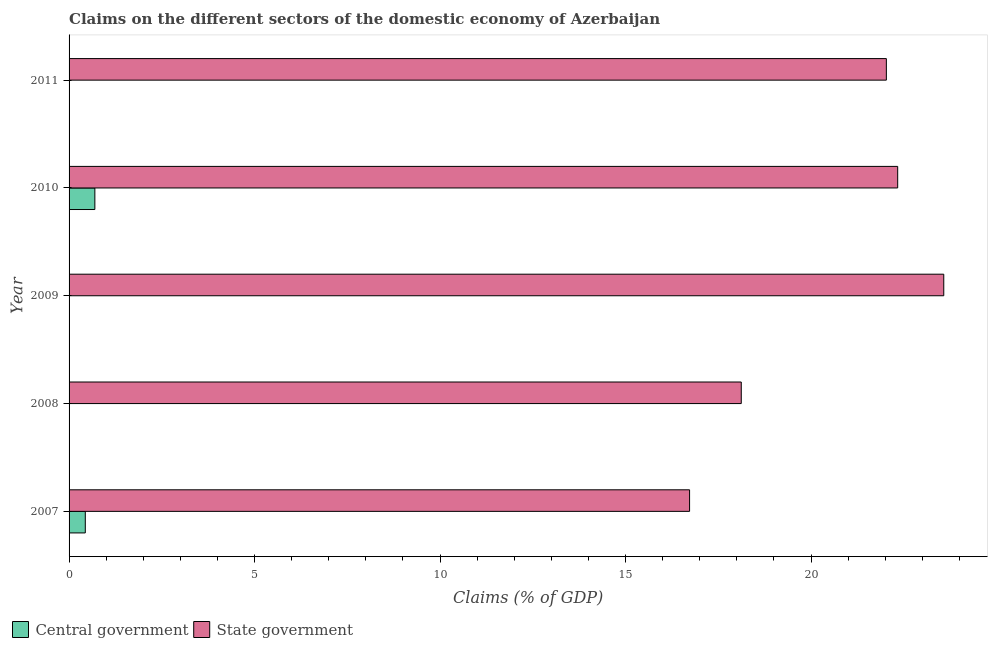How many different coloured bars are there?
Provide a succinct answer. 2. What is the label of the 1st group of bars from the top?
Provide a short and direct response. 2011. In how many cases, is the number of bars for a given year not equal to the number of legend labels?
Offer a very short reply. 3. What is the claims on state government in 2007?
Your answer should be very brief. 16.73. Across all years, what is the maximum claims on central government?
Offer a terse response. 0.69. Across all years, what is the minimum claims on state government?
Give a very brief answer. 16.73. What is the total claims on central government in the graph?
Provide a short and direct response. 1.13. What is the difference between the claims on state government in 2007 and that in 2008?
Offer a terse response. -1.39. What is the difference between the claims on state government in 2008 and the claims on central government in 2010?
Keep it short and to the point. 17.42. What is the average claims on state government per year?
Ensure brevity in your answer.  20.56. In the year 2010, what is the difference between the claims on central government and claims on state government?
Offer a very short reply. -21.64. What is the ratio of the claims on state government in 2007 to that in 2008?
Give a very brief answer. 0.92. What is the difference between the highest and the second highest claims on state government?
Your answer should be compact. 1.24. What is the difference between the highest and the lowest claims on central government?
Provide a succinct answer. 0.69. Is the sum of the claims on state government in 2009 and 2010 greater than the maximum claims on central government across all years?
Provide a short and direct response. Yes. How many bars are there?
Your answer should be compact. 7. Are all the bars in the graph horizontal?
Provide a short and direct response. Yes. What is the difference between two consecutive major ticks on the X-axis?
Keep it short and to the point. 5. Does the graph contain any zero values?
Keep it short and to the point. Yes. How many legend labels are there?
Keep it short and to the point. 2. How are the legend labels stacked?
Offer a terse response. Horizontal. What is the title of the graph?
Offer a very short reply. Claims on the different sectors of the domestic economy of Azerbaijan. Does "Commercial service exports" appear as one of the legend labels in the graph?
Your answer should be compact. No. What is the label or title of the X-axis?
Keep it short and to the point. Claims (% of GDP). What is the Claims (% of GDP) of Central government in 2007?
Your answer should be very brief. 0.44. What is the Claims (% of GDP) in State government in 2007?
Provide a succinct answer. 16.73. What is the Claims (% of GDP) in Central government in 2008?
Your answer should be very brief. 0. What is the Claims (% of GDP) of State government in 2008?
Ensure brevity in your answer.  18.12. What is the Claims (% of GDP) of Central government in 2009?
Your answer should be very brief. 0. What is the Claims (% of GDP) of State government in 2009?
Give a very brief answer. 23.58. What is the Claims (% of GDP) in Central government in 2010?
Provide a short and direct response. 0.69. What is the Claims (% of GDP) in State government in 2010?
Your answer should be compact. 22.33. What is the Claims (% of GDP) in Central government in 2011?
Your answer should be compact. 0. What is the Claims (% of GDP) of State government in 2011?
Your answer should be compact. 22.03. Across all years, what is the maximum Claims (% of GDP) of Central government?
Make the answer very short. 0.69. Across all years, what is the maximum Claims (% of GDP) in State government?
Your answer should be compact. 23.58. Across all years, what is the minimum Claims (% of GDP) in Central government?
Your answer should be compact. 0. Across all years, what is the minimum Claims (% of GDP) in State government?
Your answer should be compact. 16.73. What is the total Claims (% of GDP) in Central government in the graph?
Make the answer very short. 1.13. What is the total Claims (% of GDP) in State government in the graph?
Make the answer very short. 102.78. What is the difference between the Claims (% of GDP) of State government in 2007 and that in 2008?
Provide a short and direct response. -1.39. What is the difference between the Claims (% of GDP) of State government in 2007 and that in 2009?
Make the answer very short. -6.85. What is the difference between the Claims (% of GDP) in Central government in 2007 and that in 2010?
Give a very brief answer. -0.26. What is the difference between the Claims (% of GDP) in State government in 2007 and that in 2010?
Offer a terse response. -5.61. What is the difference between the Claims (% of GDP) of State government in 2007 and that in 2011?
Your answer should be very brief. -5.3. What is the difference between the Claims (% of GDP) of State government in 2008 and that in 2009?
Offer a very short reply. -5.46. What is the difference between the Claims (% of GDP) of State government in 2008 and that in 2010?
Your answer should be compact. -4.22. What is the difference between the Claims (% of GDP) in State government in 2008 and that in 2011?
Ensure brevity in your answer.  -3.91. What is the difference between the Claims (% of GDP) of State government in 2009 and that in 2010?
Keep it short and to the point. 1.24. What is the difference between the Claims (% of GDP) in State government in 2009 and that in 2011?
Offer a terse response. 1.55. What is the difference between the Claims (% of GDP) in State government in 2010 and that in 2011?
Offer a terse response. 0.31. What is the difference between the Claims (% of GDP) in Central government in 2007 and the Claims (% of GDP) in State government in 2008?
Your response must be concise. -17.68. What is the difference between the Claims (% of GDP) of Central government in 2007 and the Claims (% of GDP) of State government in 2009?
Offer a terse response. -23.14. What is the difference between the Claims (% of GDP) in Central government in 2007 and the Claims (% of GDP) in State government in 2010?
Give a very brief answer. -21.9. What is the difference between the Claims (% of GDP) in Central government in 2007 and the Claims (% of GDP) in State government in 2011?
Ensure brevity in your answer.  -21.59. What is the difference between the Claims (% of GDP) of Central government in 2010 and the Claims (% of GDP) of State government in 2011?
Offer a terse response. -21.33. What is the average Claims (% of GDP) in Central government per year?
Your answer should be compact. 0.23. What is the average Claims (% of GDP) in State government per year?
Ensure brevity in your answer.  20.56. In the year 2007, what is the difference between the Claims (% of GDP) of Central government and Claims (% of GDP) of State government?
Ensure brevity in your answer.  -16.29. In the year 2010, what is the difference between the Claims (% of GDP) in Central government and Claims (% of GDP) in State government?
Ensure brevity in your answer.  -21.64. What is the ratio of the Claims (% of GDP) in State government in 2007 to that in 2008?
Keep it short and to the point. 0.92. What is the ratio of the Claims (% of GDP) of State government in 2007 to that in 2009?
Give a very brief answer. 0.71. What is the ratio of the Claims (% of GDP) of Central government in 2007 to that in 2010?
Provide a short and direct response. 0.63. What is the ratio of the Claims (% of GDP) in State government in 2007 to that in 2010?
Offer a terse response. 0.75. What is the ratio of the Claims (% of GDP) of State government in 2007 to that in 2011?
Keep it short and to the point. 0.76. What is the ratio of the Claims (% of GDP) in State government in 2008 to that in 2009?
Provide a short and direct response. 0.77. What is the ratio of the Claims (% of GDP) in State government in 2008 to that in 2010?
Make the answer very short. 0.81. What is the ratio of the Claims (% of GDP) of State government in 2008 to that in 2011?
Offer a very short reply. 0.82. What is the ratio of the Claims (% of GDP) in State government in 2009 to that in 2010?
Make the answer very short. 1.06. What is the ratio of the Claims (% of GDP) of State government in 2009 to that in 2011?
Give a very brief answer. 1.07. What is the ratio of the Claims (% of GDP) in State government in 2010 to that in 2011?
Provide a succinct answer. 1.01. What is the difference between the highest and the second highest Claims (% of GDP) of State government?
Your response must be concise. 1.24. What is the difference between the highest and the lowest Claims (% of GDP) of Central government?
Make the answer very short. 0.69. What is the difference between the highest and the lowest Claims (% of GDP) of State government?
Keep it short and to the point. 6.85. 